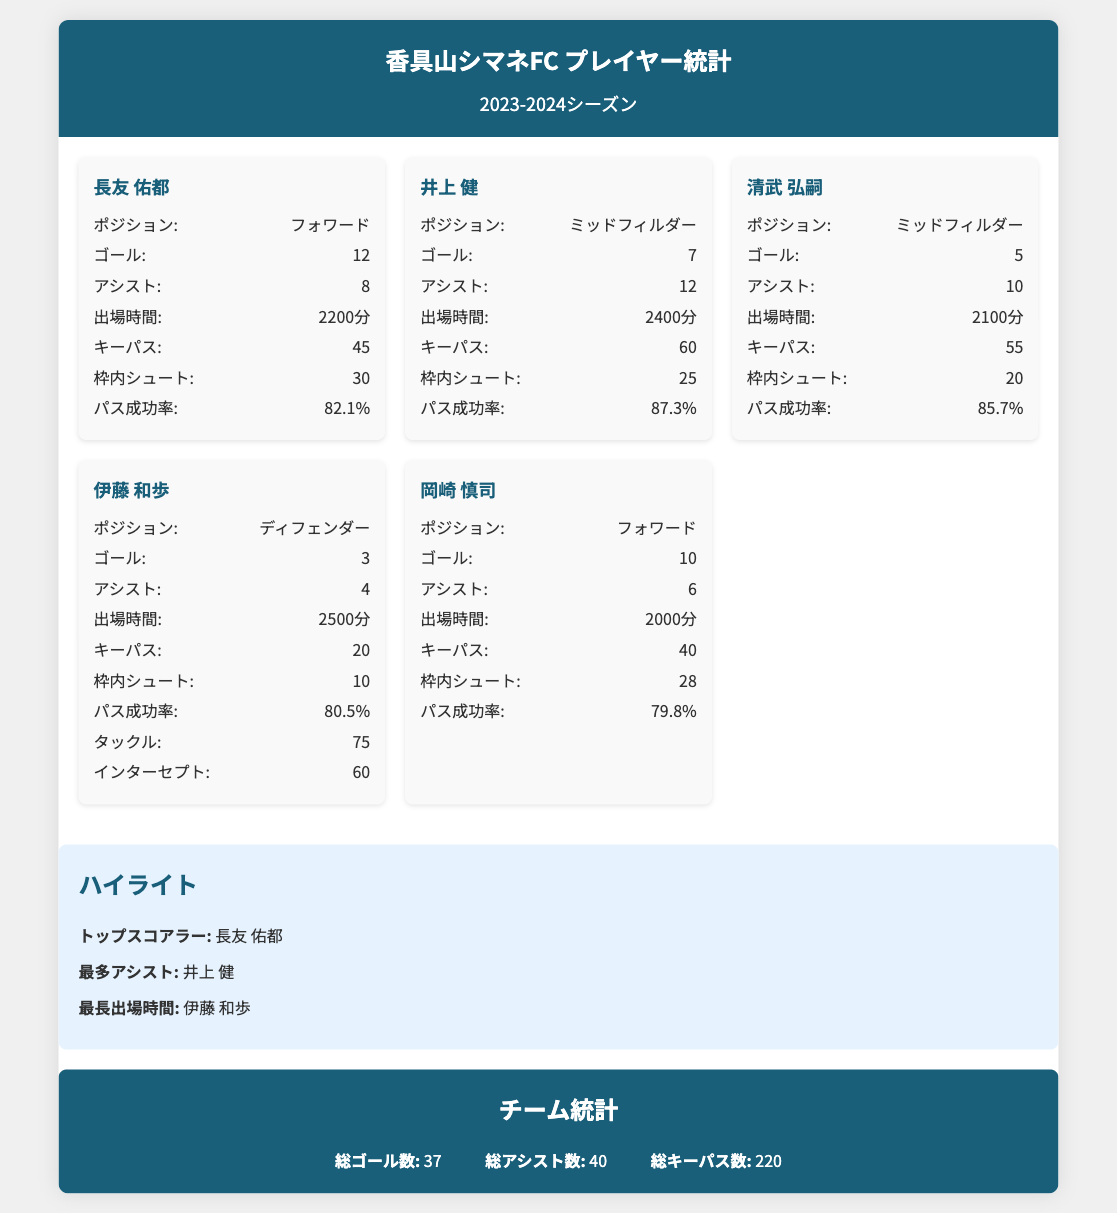何ゴールを決めたのは長友 佑都ですか？ 長友 佑都のゴール数はドキュメントに記載されているため、直接的に答えられます。
Answer: 12 井上 健のアシスト数は何ですか？ 井上 健のアシスト数は文書の中に明記されています。
Answer: 12 最長出場時間を記録した選手は誰ですか？ 出場時間に関する情報を基に、最長の出場時間を持つ選手が特定できます。
Answer: 伊藤 和歩 チームの総アシスト数はいくつですか？ チーム全体のアシスト数はドキュメントの統計部分に表記されています。
Answer: 40 枠内シュート数が最も多い選手は誰ですか？ 各選手の枠内シュート数を比較し、最も多い選手を特定します。
Answer: 長友 佑都 井上 健のパス成功率は何パーセントですか？ 井上 健のパス成功率もドキュメント内で直接確認できます。
Answer: 87.3% チームの総ゴール数はどれくらいですか？ チーム統計の部分に総ゴール数が記載されています。
Answer: 37 最も多くアシストをした選手は誰ですか？ アシスト数のデータを参照し、最も多くアシストした選手を確認できます。
Answer: 井上 健 伊藤 和歩のタックル数はいくつですか？ 伊藤 和歩のタックル数はドキュメント内で示されています。
Answer: 75 清武 弘嗣のゴール数は何ですか？ 清武 弘嗣のゴール数は選手カードに記載されているため、簡単に確認できます。
Answer: 5 